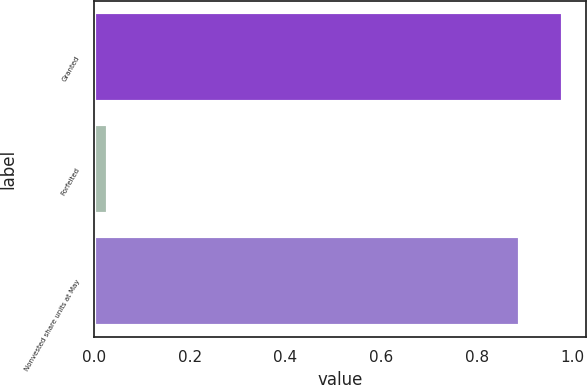<chart> <loc_0><loc_0><loc_500><loc_500><bar_chart><fcel>Granted<fcel>Forfeited<fcel>Nonvested share units at May<nl><fcel>0.98<fcel>0.03<fcel>0.89<nl></chart> 